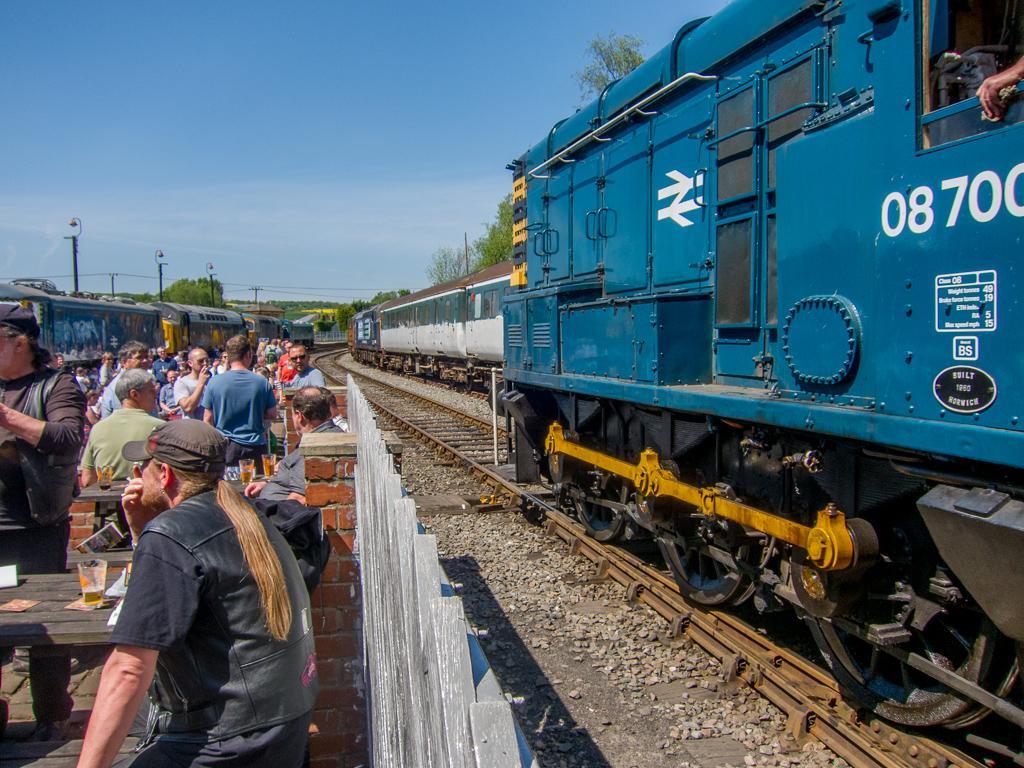What numbers are on the train?
Ensure brevity in your answer.  08700. 